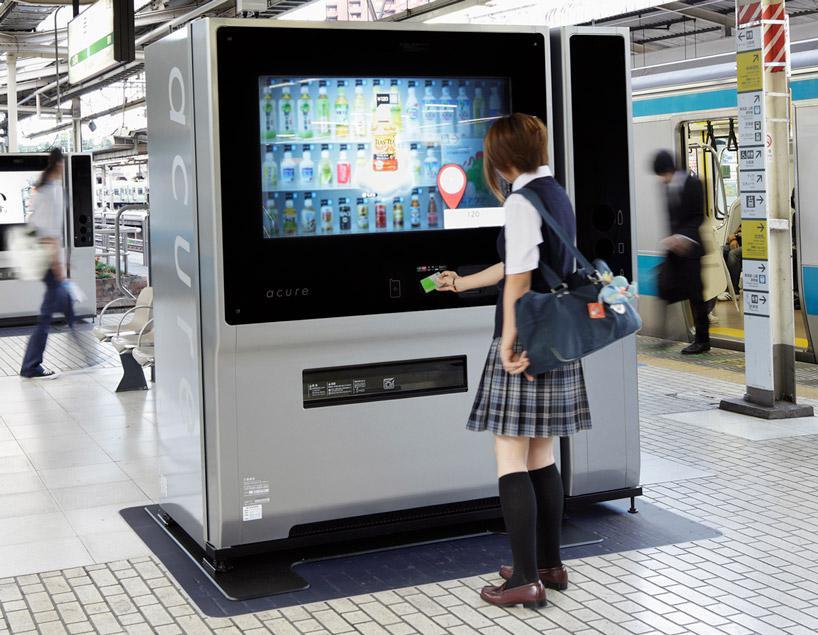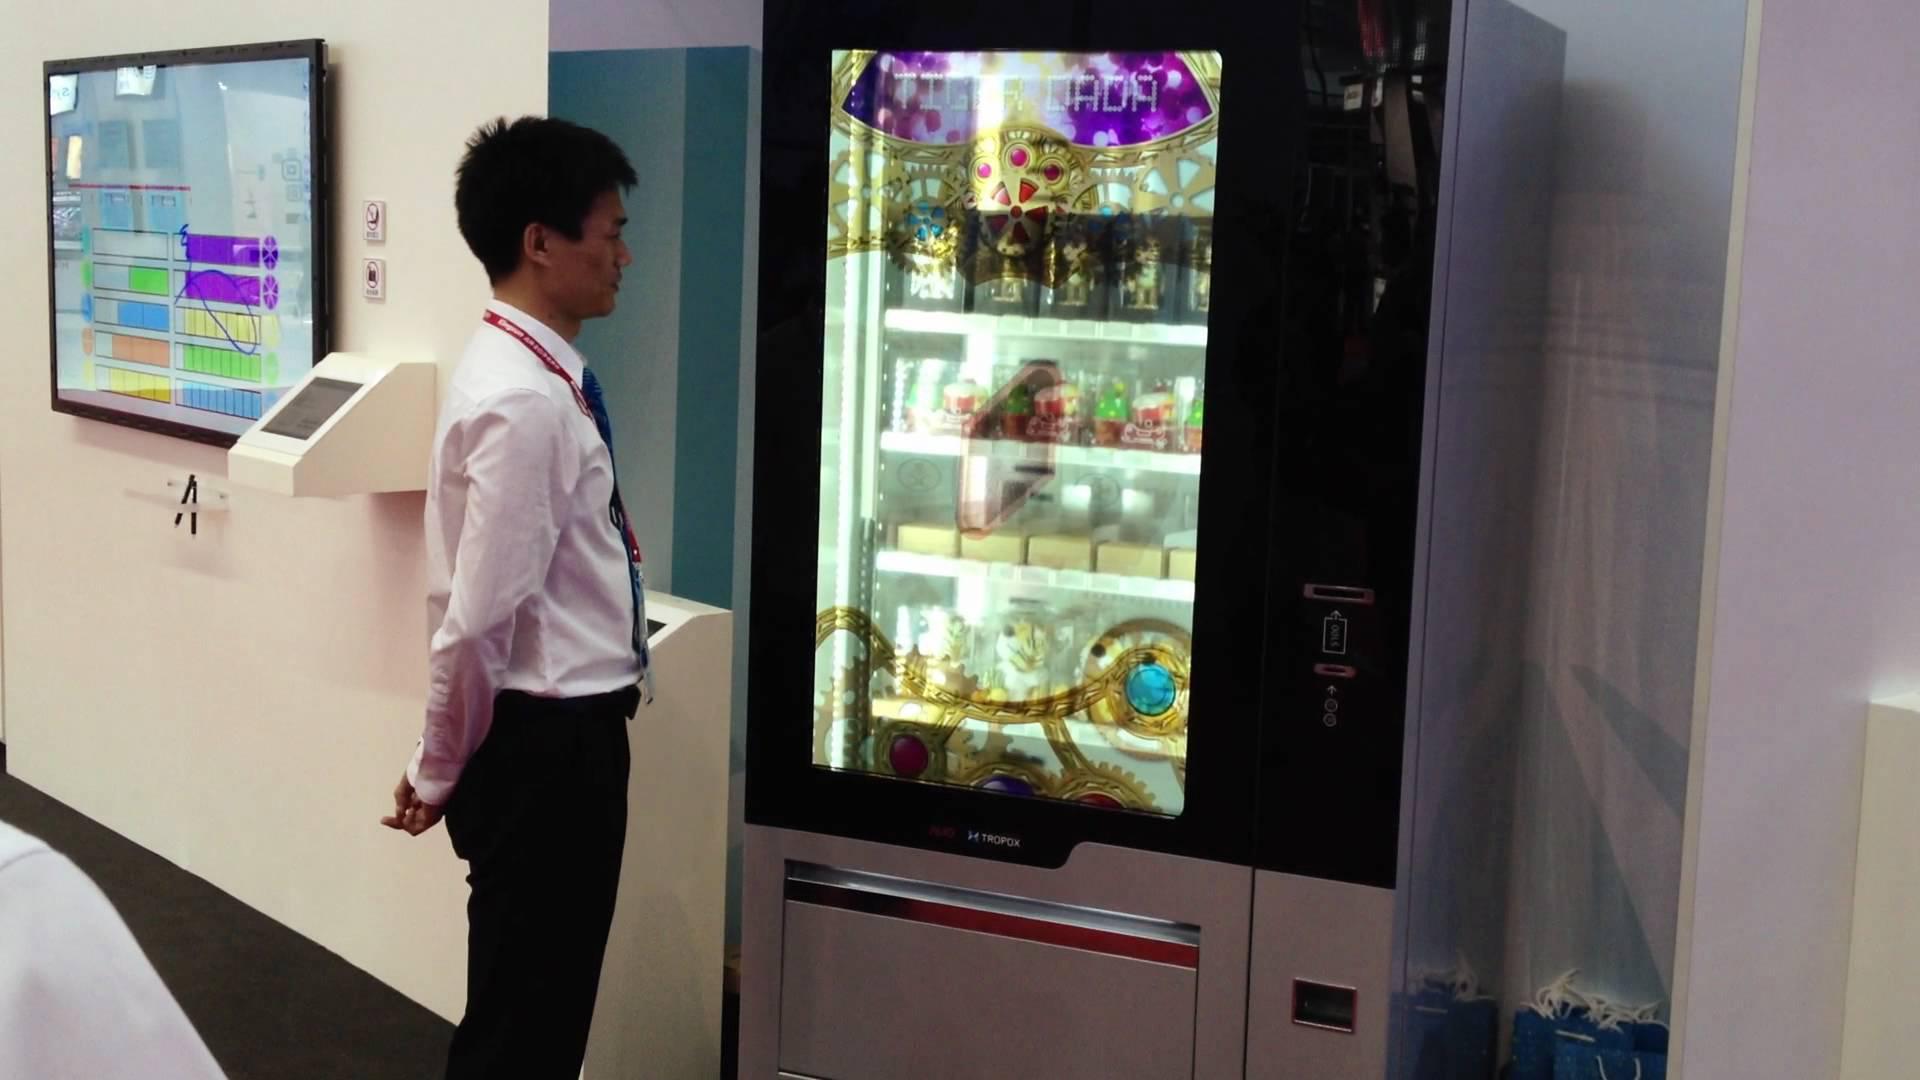The first image is the image on the left, the second image is the image on the right. Assess this claim about the two images: "Neither image has an actual human being that is standing up.". Correct or not? Answer yes or no. No. The first image is the image on the left, the second image is the image on the right. Considering the images on both sides, is "Somewhere in one image, a back-turned person stands in front of a lit screen of some type." valid? Answer yes or no. Yes. 